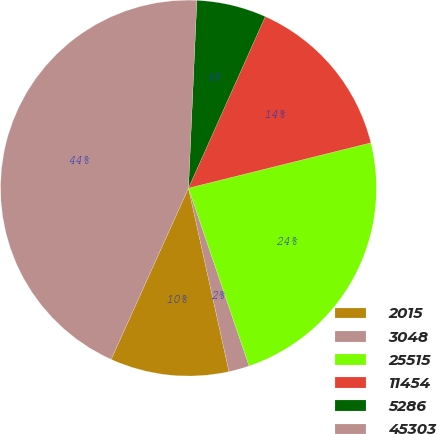Convert chart. <chart><loc_0><loc_0><loc_500><loc_500><pie_chart><fcel>2015<fcel>3048<fcel>25515<fcel>11454<fcel>5286<fcel>45303<nl><fcel>10.21%<fcel>1.77%<fcel>23.65%<fcel>14.43%<fcel>5.99%<fcel>43.97%<nl></chart> 